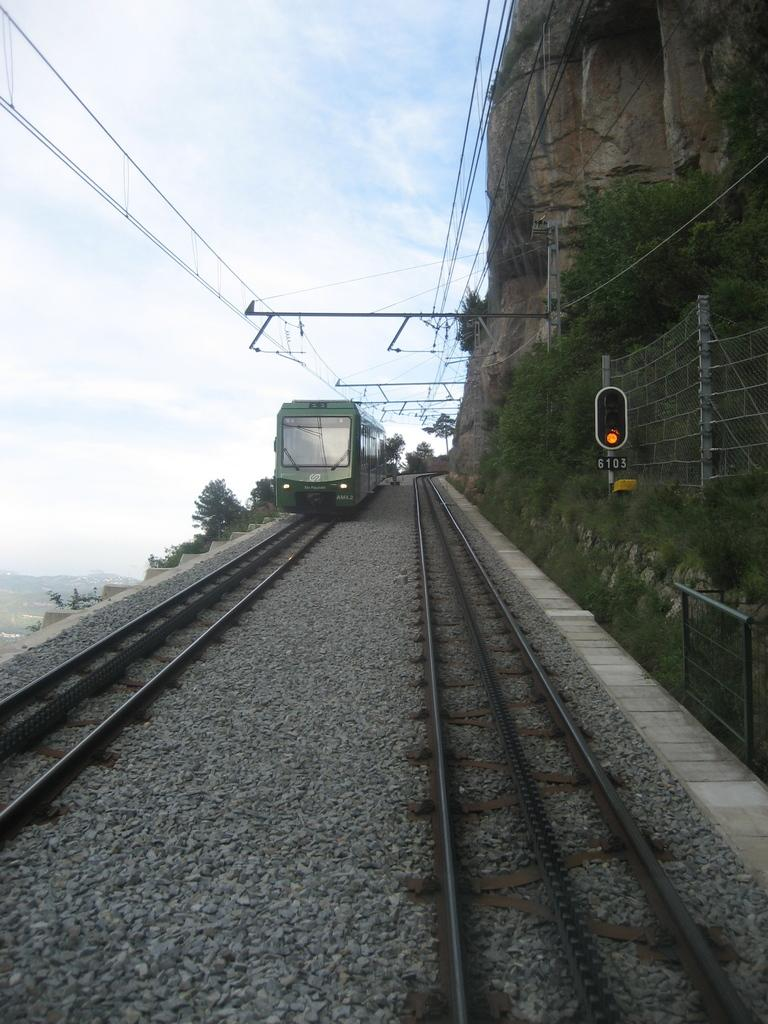What is the main subject of the image? The main subject of the image is a train on a railway track. What else can be seen in the image besides the train? There is a traffic signal light, a fence, a path, wires, trees, and the sky with clouds visible in the background of the image. Can you see the legs of the train conductor in the image? There is no train conductor or their legs visible in the image. What type of locket is hanging from the trees in the image? There is no locket present in the image; it features a train, traffic signal light, fence, path, wires, trees, and the sky with clouds. 